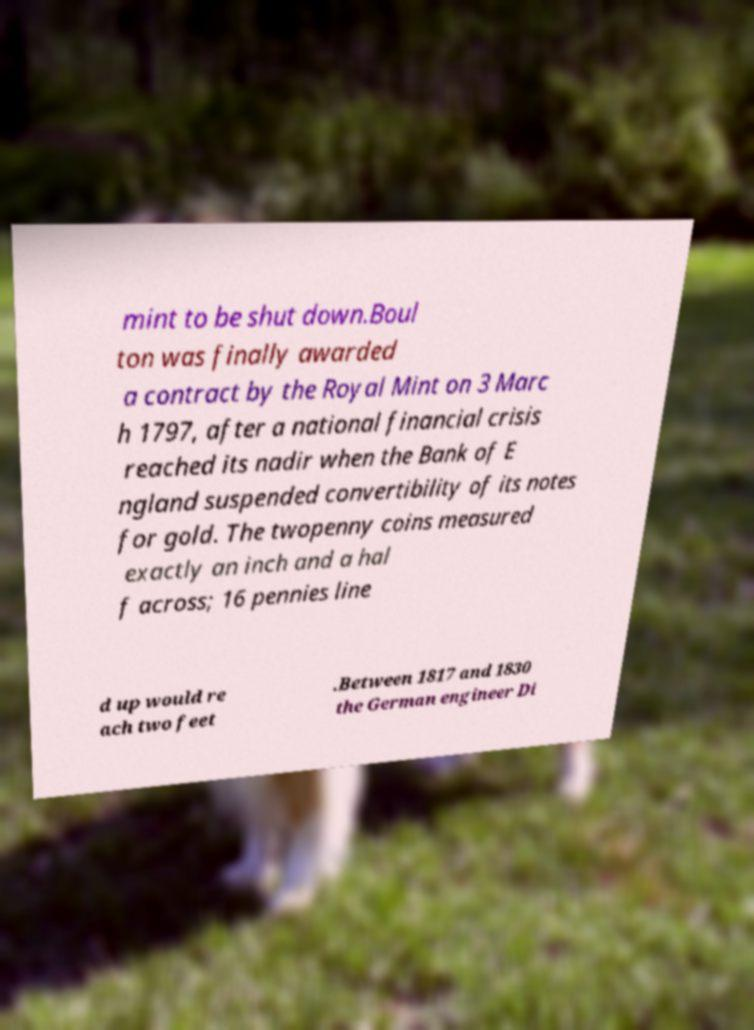Please identify and transcribe the text found in this image. mint to be shut down.Boul ton was finally awarded a contract by the Royal Mint on 3 Marc h 1797, after a national financial crisis reached its nadir when the Bank of E ngland suspended convertibility of its notes for gold. The twopenny coins measured exactly an inch and a hal f across; 16 pennies line d up would re ach two feet .Between 1817 and 1830 the German engineer Di 